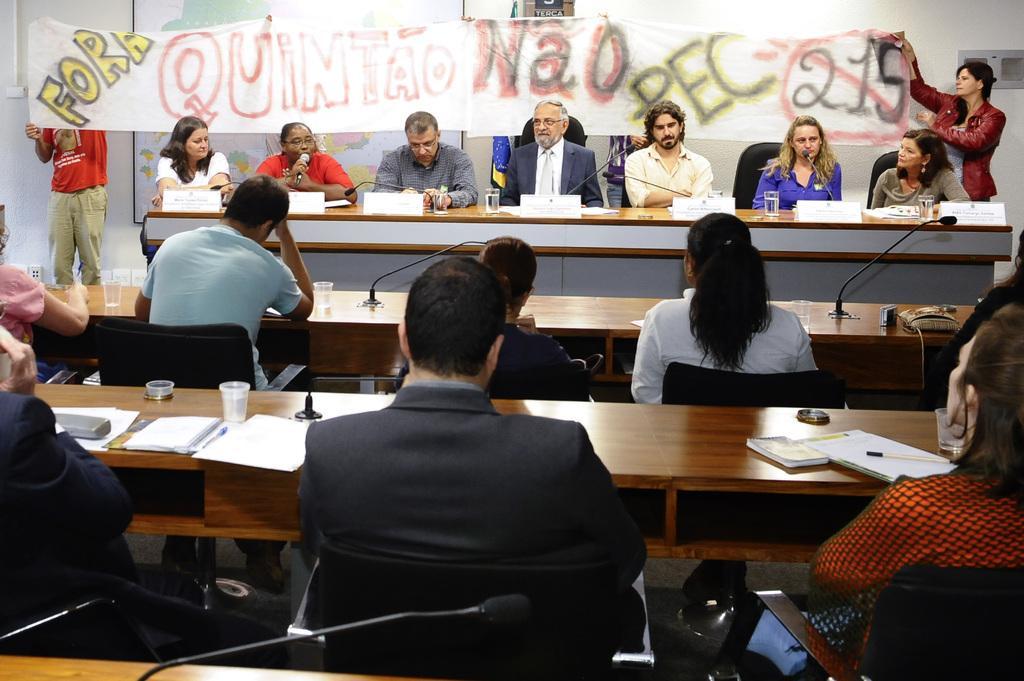Can you describe this image briefly? In this image we can see many people are sitting on the table. And we can see one woman giving a speech. And we can see the books on the table. And we can see the glass on the table. And in the background we can see the banner with written text. 